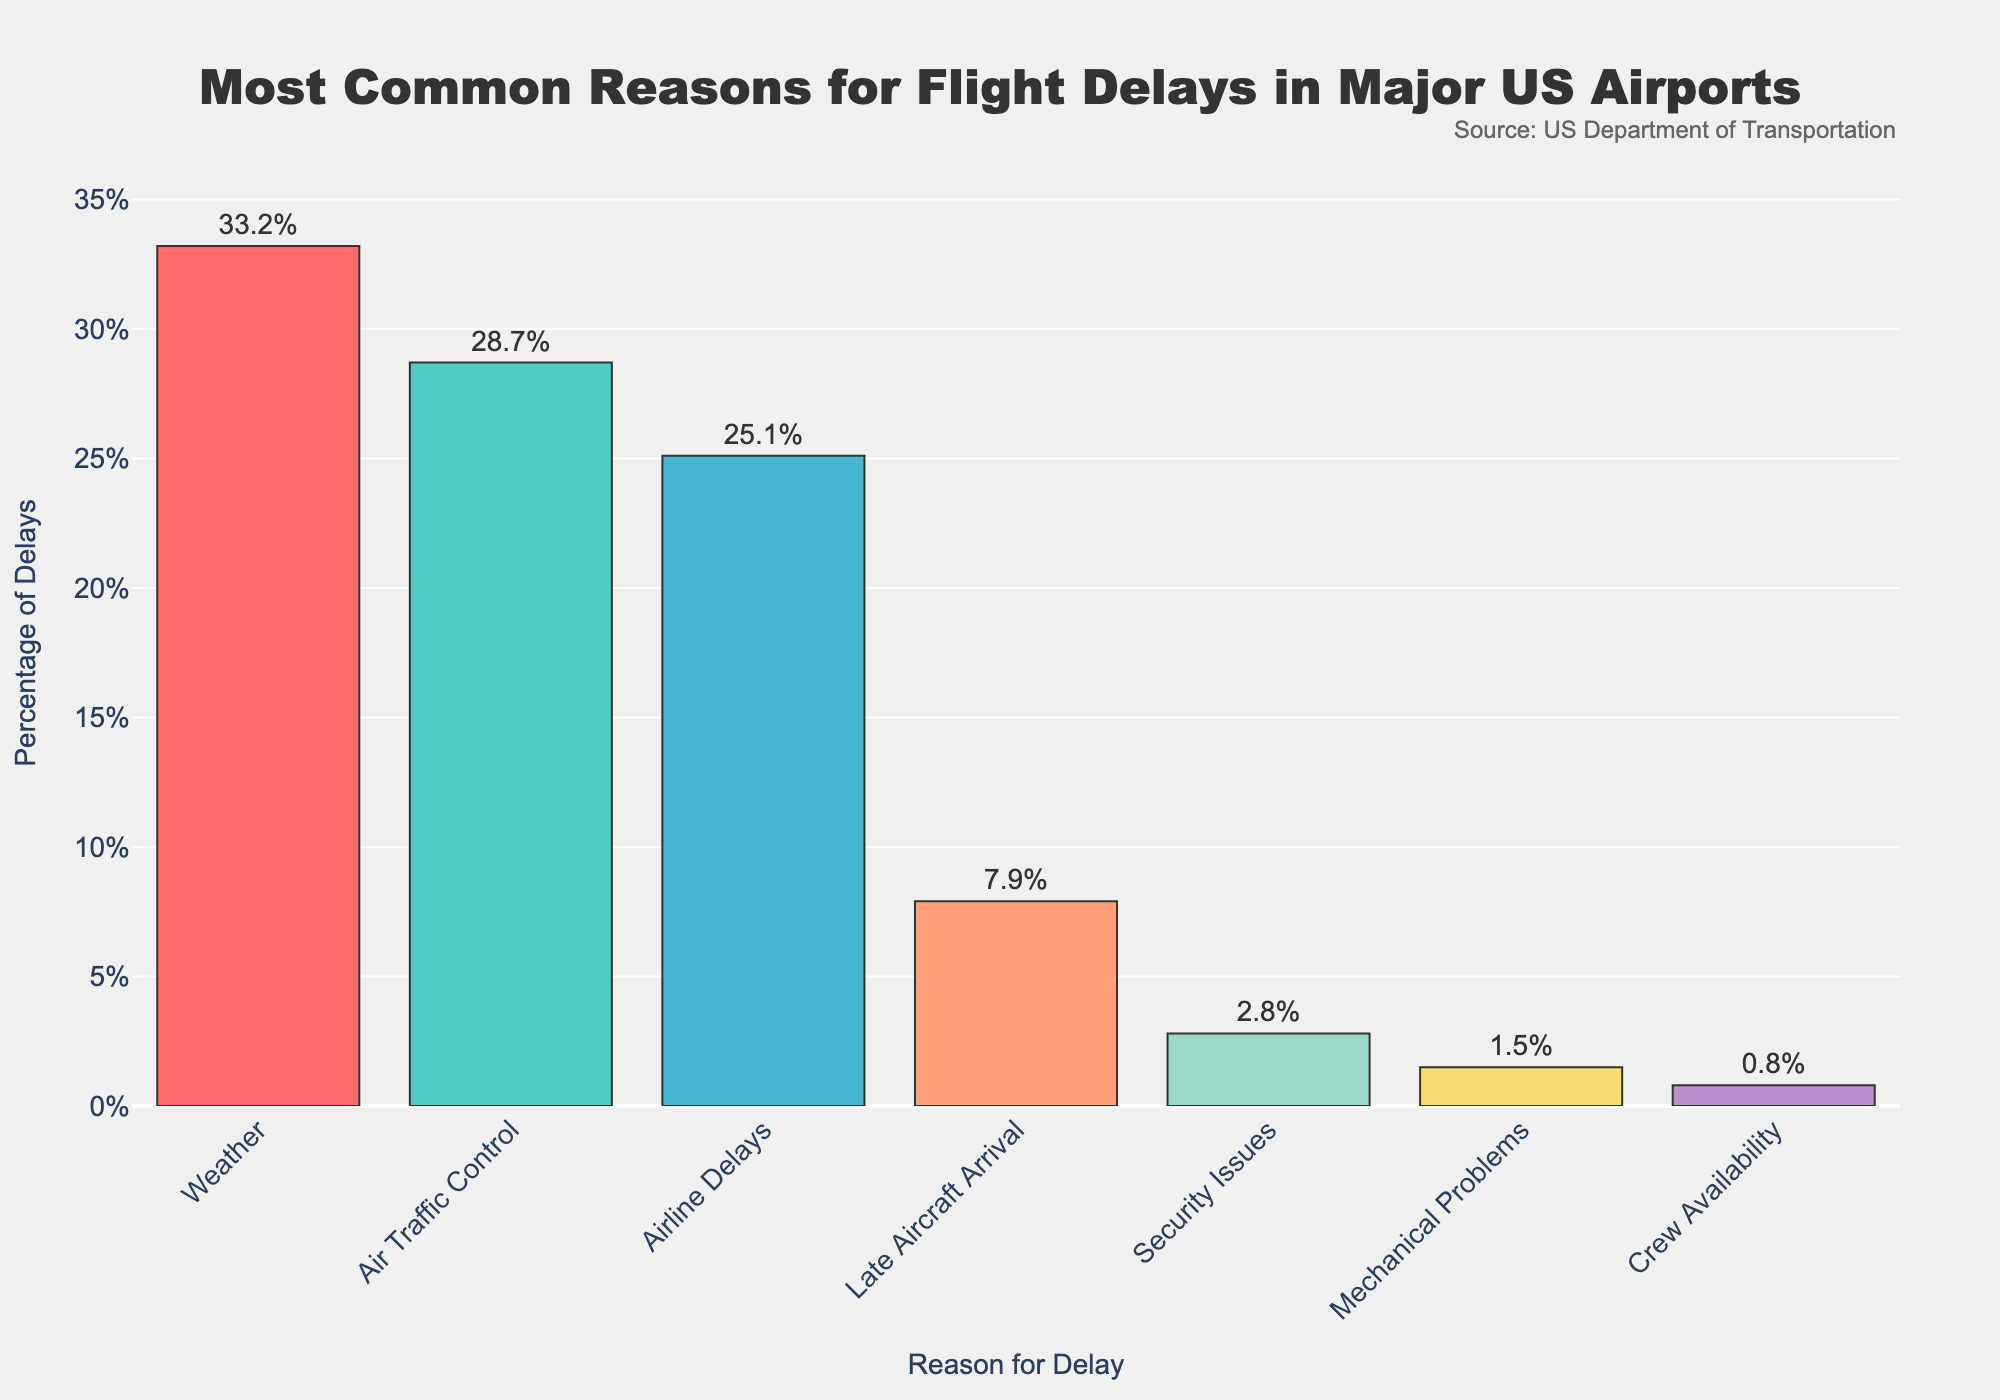Which reason is the most common for flight delays? The figure shows that "Weather" has the highest bar, indicating it accounts for the largest percentage of delays.
Answer: Weather What percentage of delays are caused by Air Traffic Control? The figure indicates that "Air Traffic Control" has a label showing 28.7%, which denotes its share of the total delays.
Answer: 28.7% Which reason contributes the least to flight delays? The shortest bar in the chart belongs to "Crew Availability," indicating it has the smallest percentage.
Answer: Crew Availability By how much does the percentage of "Weather" delays exceed that of "Mechanical Problems"? The percentage for "Weather" is 33.2% and for "Mechanical Problems" is 1.5%. The difference is 33.2% - 1.5% = 31.7%.
Answer: 31.7% What are the combined percentages of delays caused by Airline Delays and Late Aircraft Arrival? The figure shows Airline Delays at 25.1% and Late Aircraft Arrival at 7.9%. Adding these together gives 25.1% + 7.9% = 33%.
Answer: 33% Is the percentage of Security Issues greater than Mechanical Problems? The figure shows Security Issues at 2.8% and Mechanical Problems at 1.5%. Since 2.8% is greater than 1.5%, the statement is true.
Answer: Yes Which reasons have percentages over 20%? The figure shows "Weather" at 33.2%, "Air Traffic Control" at 28.7%, and "Airline Delays" at 25.1%. All of these are above 20%.
Answer: Weather, Air Traffic Control, Airline Delays How many reasons account for less than 10% of delays each? The figure displays four reasons under 10%: Late Aircraft Arrival at 7.9%, Security Issues at 2.8%, Mechanical Problems at 1.5%, and Crew Availability at 0.8%.
Answer: Four Which reasons are represented by green and light blue bars? In the chart, the green bar represents "Air Traffic Control" and the light blue bar represents "Airline Delays."
Answer: Air Traffic Control, Airline Delays What is the average percentage of delays for Late Aircraft Arrival, Security Issues, and Mechanical Problems? The percentages are 7.9%, 2.8%, and 1.5%. The average is calculated as (7.9 + 2.8 + 1.5) / 3 = 4.07%.
Answer: 4.07% 